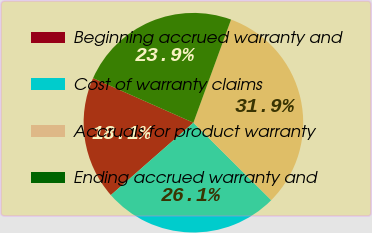<chart> <loc_0><loc_0><loc_500><loc_500><pie_chart><fcel>Beginning accrued warranty and<fcel>Cost of warranty claims<fcel>Accruals for product warranty<fcel>Ending accrued warranty and<nl><fcel>18.11%<fcel>26.08%<fcel>31.89%<fcel>23.92%<nl></chart> 